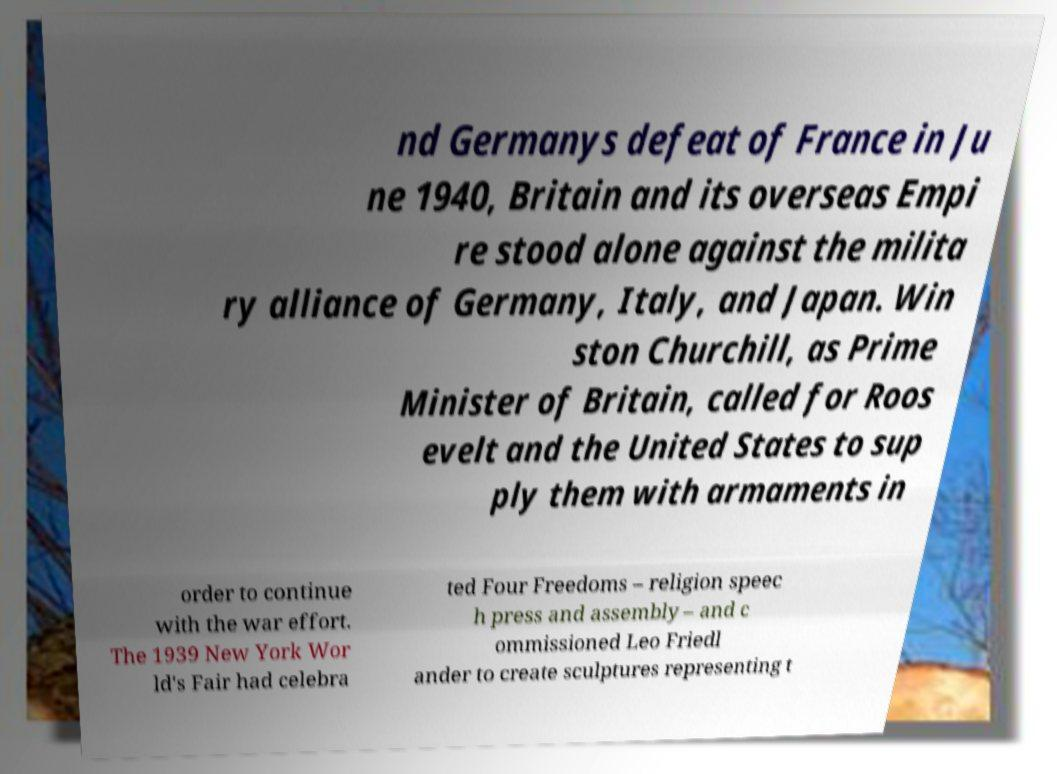Can you accurately transcribe the text from the provided image for me? nd Germanys defeat of France in Ju ne 1940, Britain and its overseas Empi re stood alone against the milita ry alliance of Germany, Italy, and Japan. Win ston Churchill, as Prime Minister of Britain, called for Roos evelt and the United States to sup ply them with armaments in order to continue with the war effort. The 1939 New York Wor ld's Fair had celebra ted Four Freedoms – religion speec h press and assembly – and c ommissioned Leo Friedl ander to create sculptures representing t 